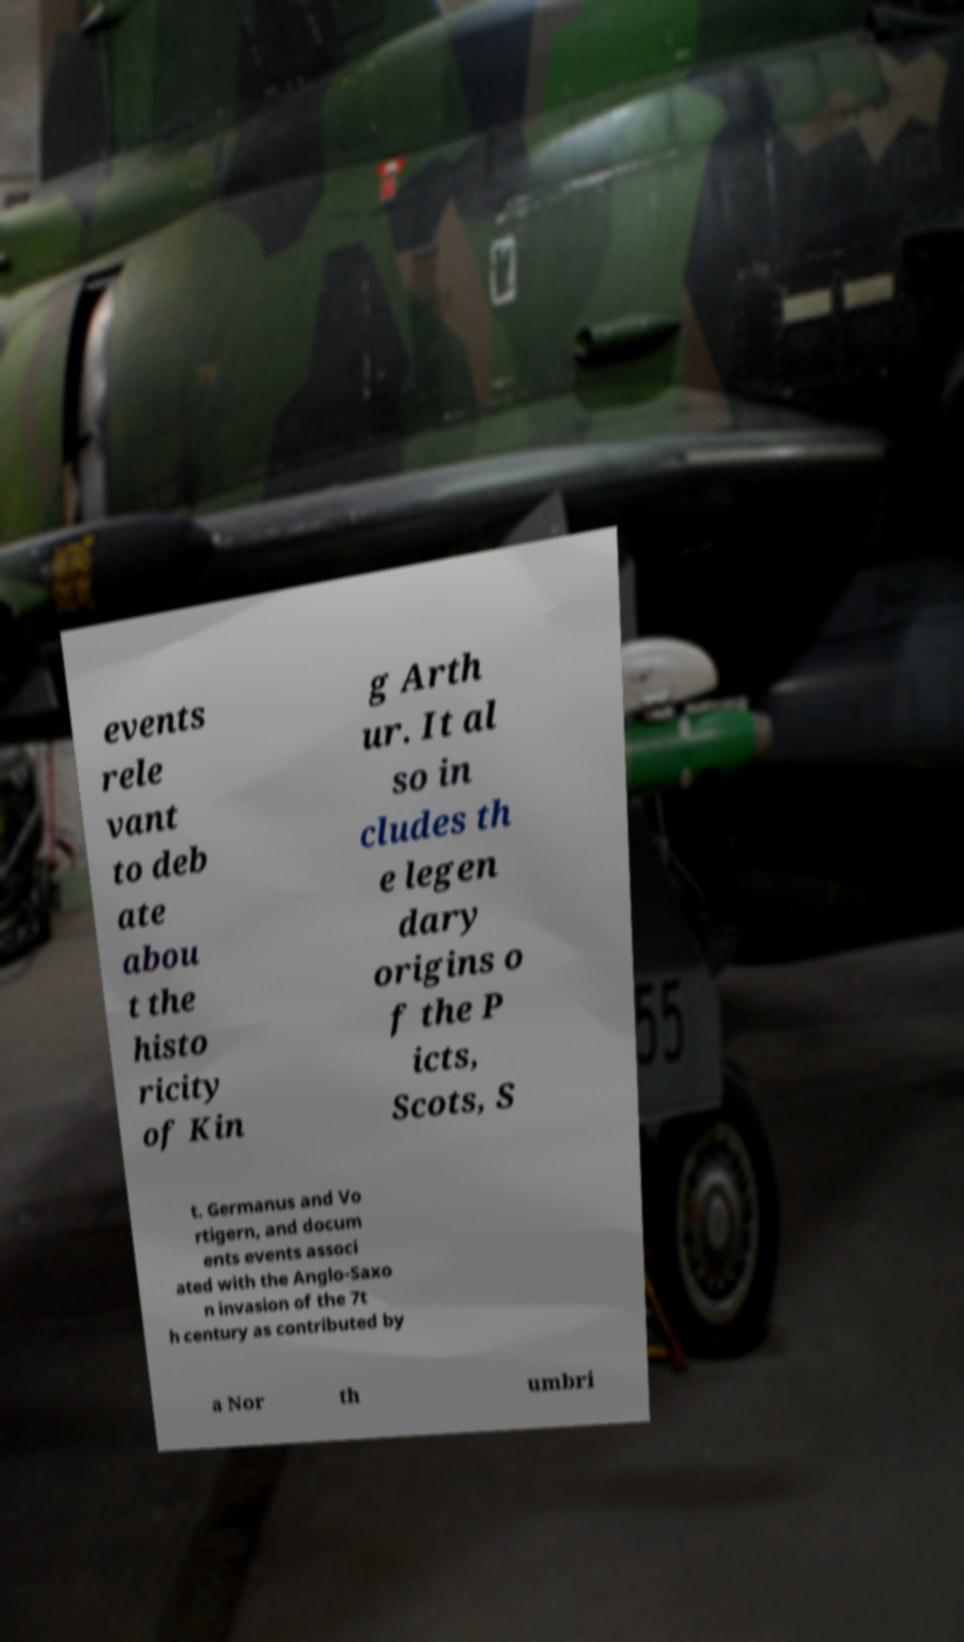Please read and relay the text visible in this image. What does it say? events rele vant to deb ate abou t the histo ricity of Kin g Arth ur. It al so in cludes th e legen dary origins o f the P icts, Scots, S t. Germanus and Vo rtigern, and docum ents events associ ated with the Anglo-Saxo n invasion of the 7t h century as contributed by a Nor th umbri 